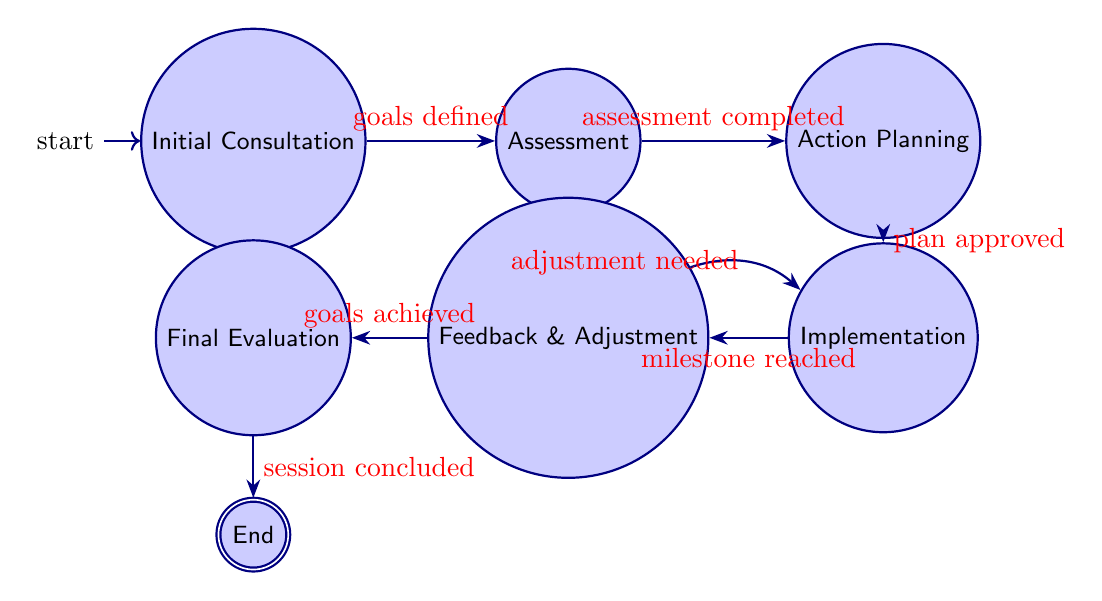What is the first state in the diagram? The first state is depicted as the starting point in the diagram, which is labeled as "Initial Consultation."
Answer: Initial Consultation How many states are there in total? Counting all the states listed in the diagram, there are six states present: Initial Consultation, Assessment, Action Planning, Implementation, Feedback and Adjustment, Final Evaluation, and End.
Answer: 6 What event triggers the transition from Assessment to Action Planning? The event specified in the diagram that initiates the transition is labeled as "assessment completed." This event connects the two states directly.
Answer: assessment completed Which state comes after Action Planning? Based on the arrow direction in the diagram, immediately following the state of Action Planning is the state of Implementation. This is indicated by the transition defined in the diagram.
Answer: Implementation What happens if goals are achieved in the Feedback and Adjustment state? According to the diagram, if the goals are achieved in the Feedback and Adjustment state, there is a transition to the Final Evaluation state. This indicates that reaching goals triggers this movement to the next state.
Answer: Final Evaluation What is the final state of the coaching session structure? The last state depicted in the diagram, which signifies the completion of the coaching process, is labeled as "End." This indicates that the session has concluded successfully.
Answer: End If a milestone is reached in Implementation, where does it lead? The diagram shows that reaching a milestone in the Implementation state leads directly to the Feedback and Adjustment state, indicating a review process.
Answer: Feedback and Adjustment What must be defined first before moving to the Assessment state? The diagram specifies that a prerequisite event for moving from Initial Consultation to Assessment is that the "goals defined" event must occur first.
Answer: goals defined 